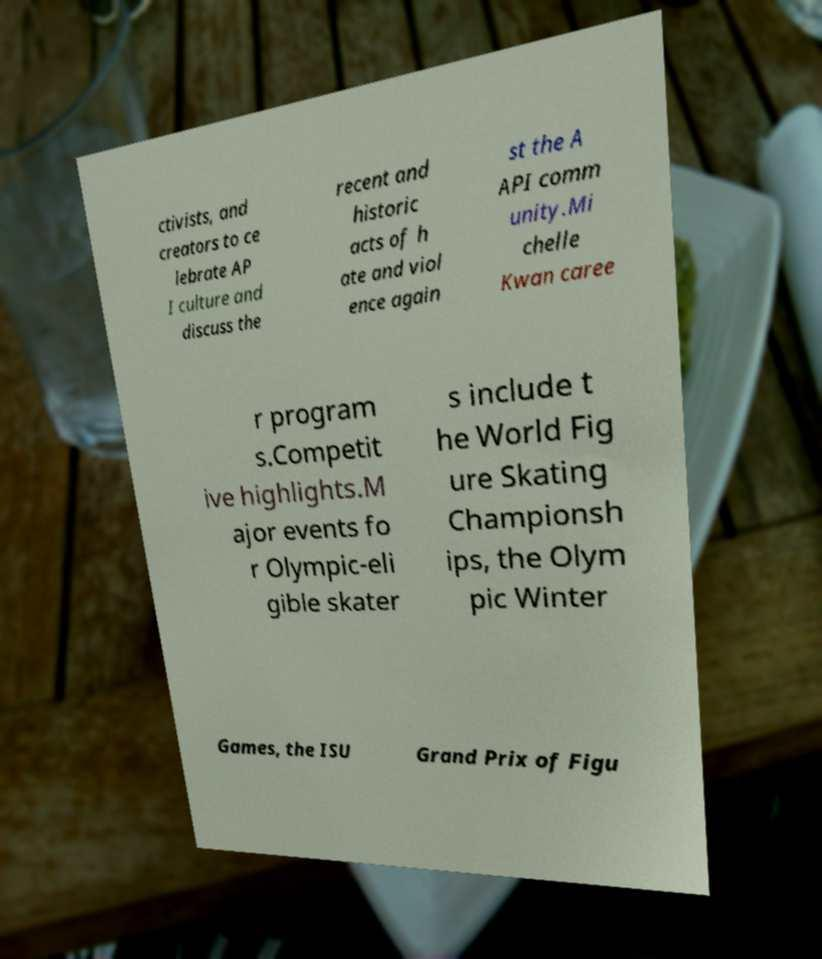Could you extract and type out the text from this image? ctivists, and creators to ce lebrate AP I culture and discuss the recent and historic acts of h ate and viol ence again st the A API comm unity.Mi chelle Kwan caree r program s.Competit ive highlights.M ajor events fo r Olympic-eli gible skater s include t he World Fig ure Skating Championsh ips, the Olym pic Winter Games, the ISU Grand Prix of Figu 